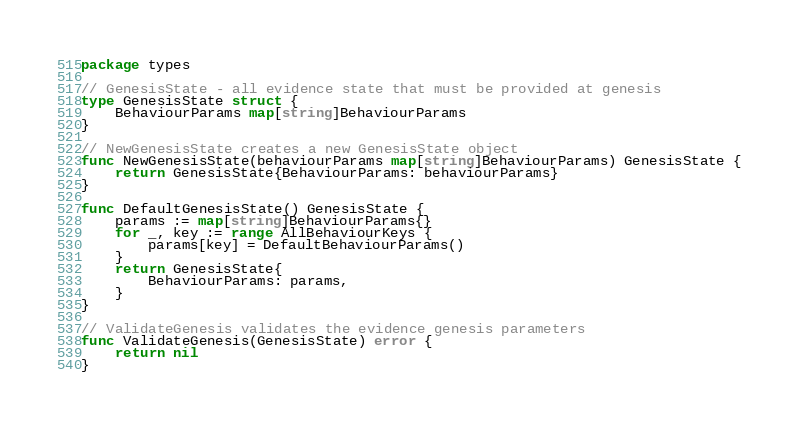Convert code to text. <code><loc_0><loc_0><loc_500><loc_500><_Go_>package types

// GenesisState - all evidence state that must be provided at genesis
type GenesisState struct {
	BehaviourParams map[string]BehaviourParams
}

// NewGenesisState creates a new GenesisState object
func NewGenesisState(behaviourParams map[string]BehaviourParams) GenesisState {
	return GenesisState{BehaviourParams: behaviourParams}
}

func DefaultGenesisState() GenesisState {
	params := map[string]BehaviourParams{}
	for _, key := range AllBehaviourKeys {
		params[key] = DefaultBehaviourParams()
	}
	return GenesisState{
		BehaviourParams: params,
	}
}

// ValidateGenesis validates the evidence genesis parameters
func ValidateGenesis(GenesisState) error {
	return nil
}
</code> 